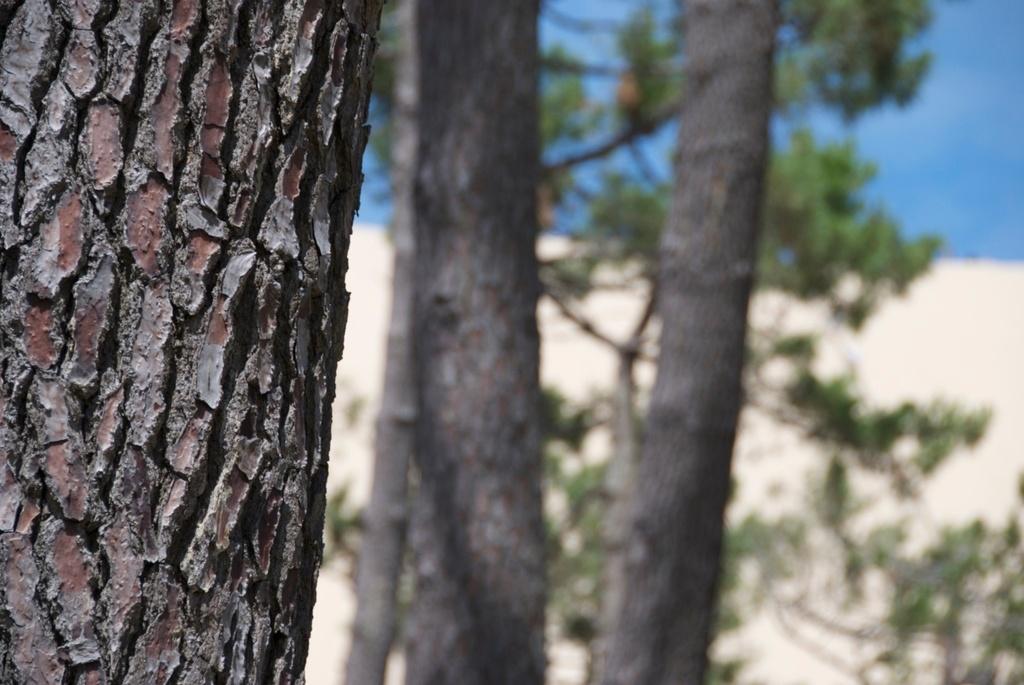Please provide a concise description of this image. In this image I can see the trunk, background I can see few trees in green color and the sky is in blue color. 